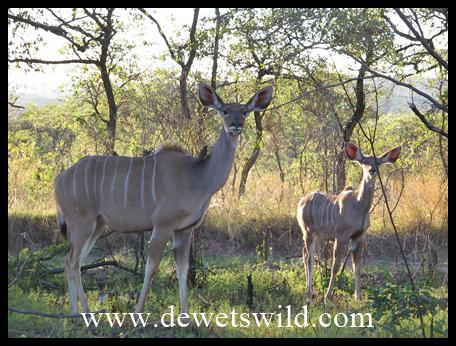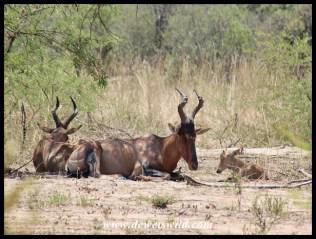The first image is the image on the left, the second image is the image on the right. Given the left and right images, does the statement "All the animals have horns." hold true? Answer yes or no. No. The first image is the image on the left, the second image is the image on the right. For the images displayed, is the sentence "One image contains at least one hornless deer-like animal with vertical white stripes, and the other image features multiple animals with curved horns and at least one reclining animal." factually correct? Answer yes or no. Yes. 